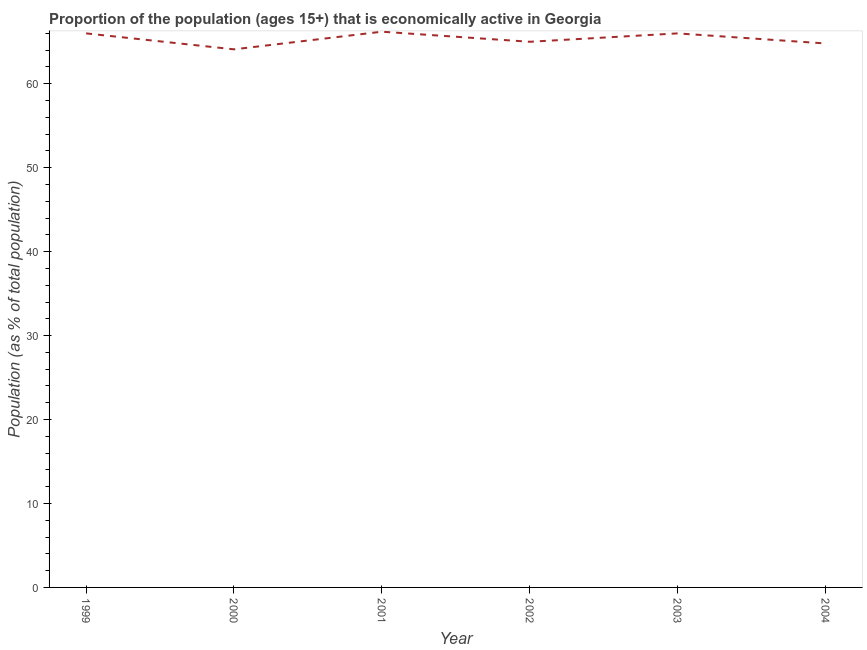Across all years, what is the maximum percentage of economically active population?
Your answer should be very brief. 66.2. Across all years, what is the minimum percentage of economically active population?
Your answer should be very brief. 64.1. In which year was the percentage of economically active population minimum?
Your answer should be compact. 2000. What is the sum of the percentage of economically active population?
Your answer should be very brief. 392.1. What is the difference between the percentage of economically active population in 2001 and 2003?
Your answer should be very brief. 0.2. What is the average percentage of economically active population per year?
Offer a terse response. 65.35. What is the median percentage of economically active population?
Offer a very short reply. 65.5. What is the ratio of the percentage of economically active population in 2002 to that in 2004?
Make the answer very short. 1. Is the percentage of economically active population in 2001 less than that in 2002?
Offer a terse response. No. What is the difference between the highest and the second highest percentage of economically active population?
Keep it short and to the point. 0.2. What is the difference between the highest and the lowest percentage of economically active population?
Your answer should be compact. 2.1. Does the percentage of economically active population monotonically increase over the years?
Your answer should be compact. No. Are the values on the major ticks of Y-axis written in scientific E-notation?
Keep it short and to the point. No. What is the title of the graph?
Ensure brevity in your answer.  Proportion of the population (ages 15+) that is economically active in Georgia. What is the label or title of the X-axis?
Keep it short and to the point. Year. What is the label or title of the Y-axis?
Provide a short and direct response. Population (as % of total population). What is the Population (as % of total population) in 1999?
Give a very brief answer. 66. What is the Population (as % of total population) of 2000?
Provide a succinct answer. 64.1. What is the Population (as % of total population) in 2001?
Ensure brevity in your answer.  66.2. What is the Population (as % of total population) in 2003?
Provide a succinct answer. 66. What is the Population (as % of total population) in 2004?
Your answer should be compact. 64.8. What is the difference between the Population (as % of total population) in 1999 and 2001?
Provide a short and direct response. -0.2. What is the difference between the Population (as % of total population) in 1999 and 2002?
Your answer should be compact. 1. What is the difference between the Population (as % of total population) in 1999 and 2003?
Provide a short and direct response. 0. What is the difference between the Population (as % of total population) in 2000 and 2004?
Your response must be concise. -0.7. What is the difference between the Population (as % of total population) in 2001 and 2004?
Your answer should be very brief. 1.4. What is the difference between the Population (as % of total population) in 2002 and 2004?
Keep it short and to the point. 0.2. What is the ratio of the Population (as % of total population) in 1999 to that in 2000?
Provide a succinct answer. 1.03. What is the ratio of the Population (as % of total population) in 2000 to that in 2001?
Offer a very short reply. 0.97. What is the ratio of the Population (as % of total population) in 2000 to that in 2002?
Offer a terse response. 0.99. What is the ratio of the Population (as % of total population) in 2000 to that in 2004?
Make the answer very short. 0.99. What is the ratio of the Population (as % of total population) in 2001 to that in 2003?
Make the answer very short. 1. 